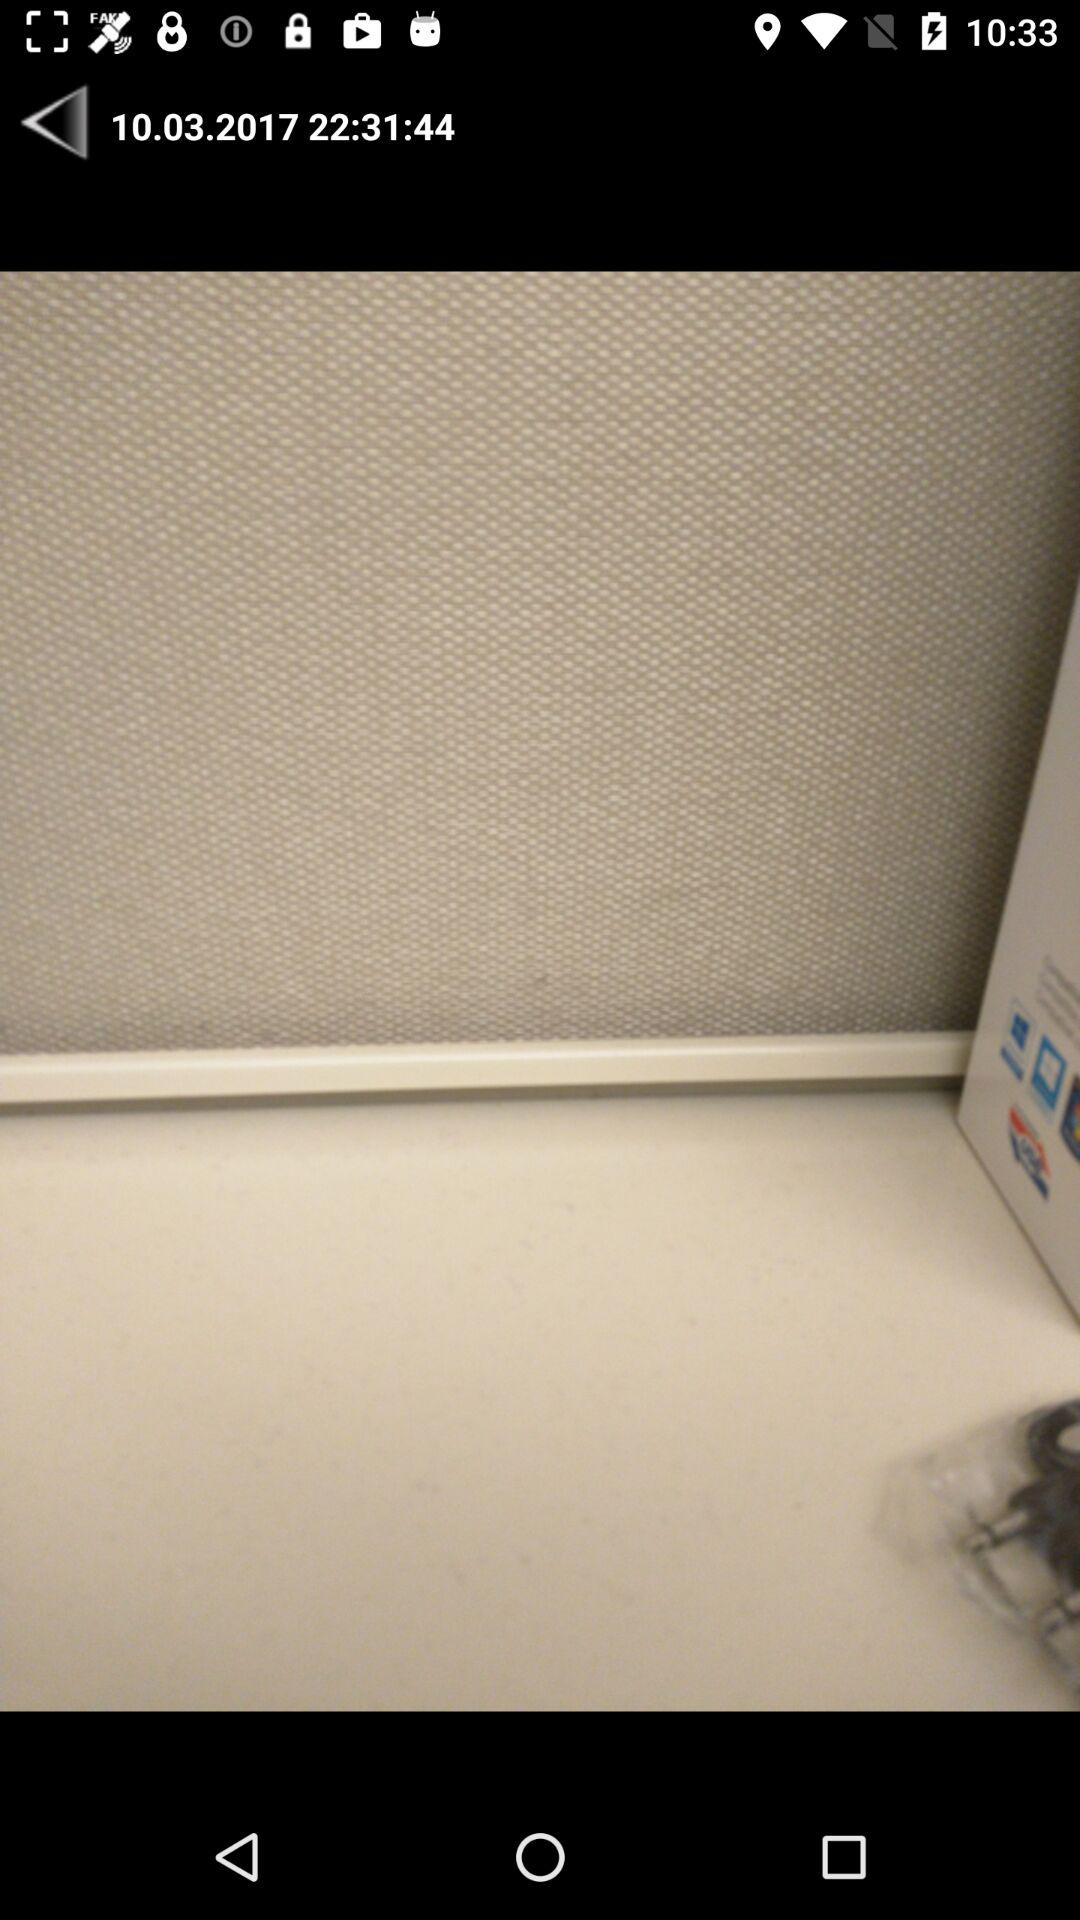What is the time? The time is 22:31:44. 